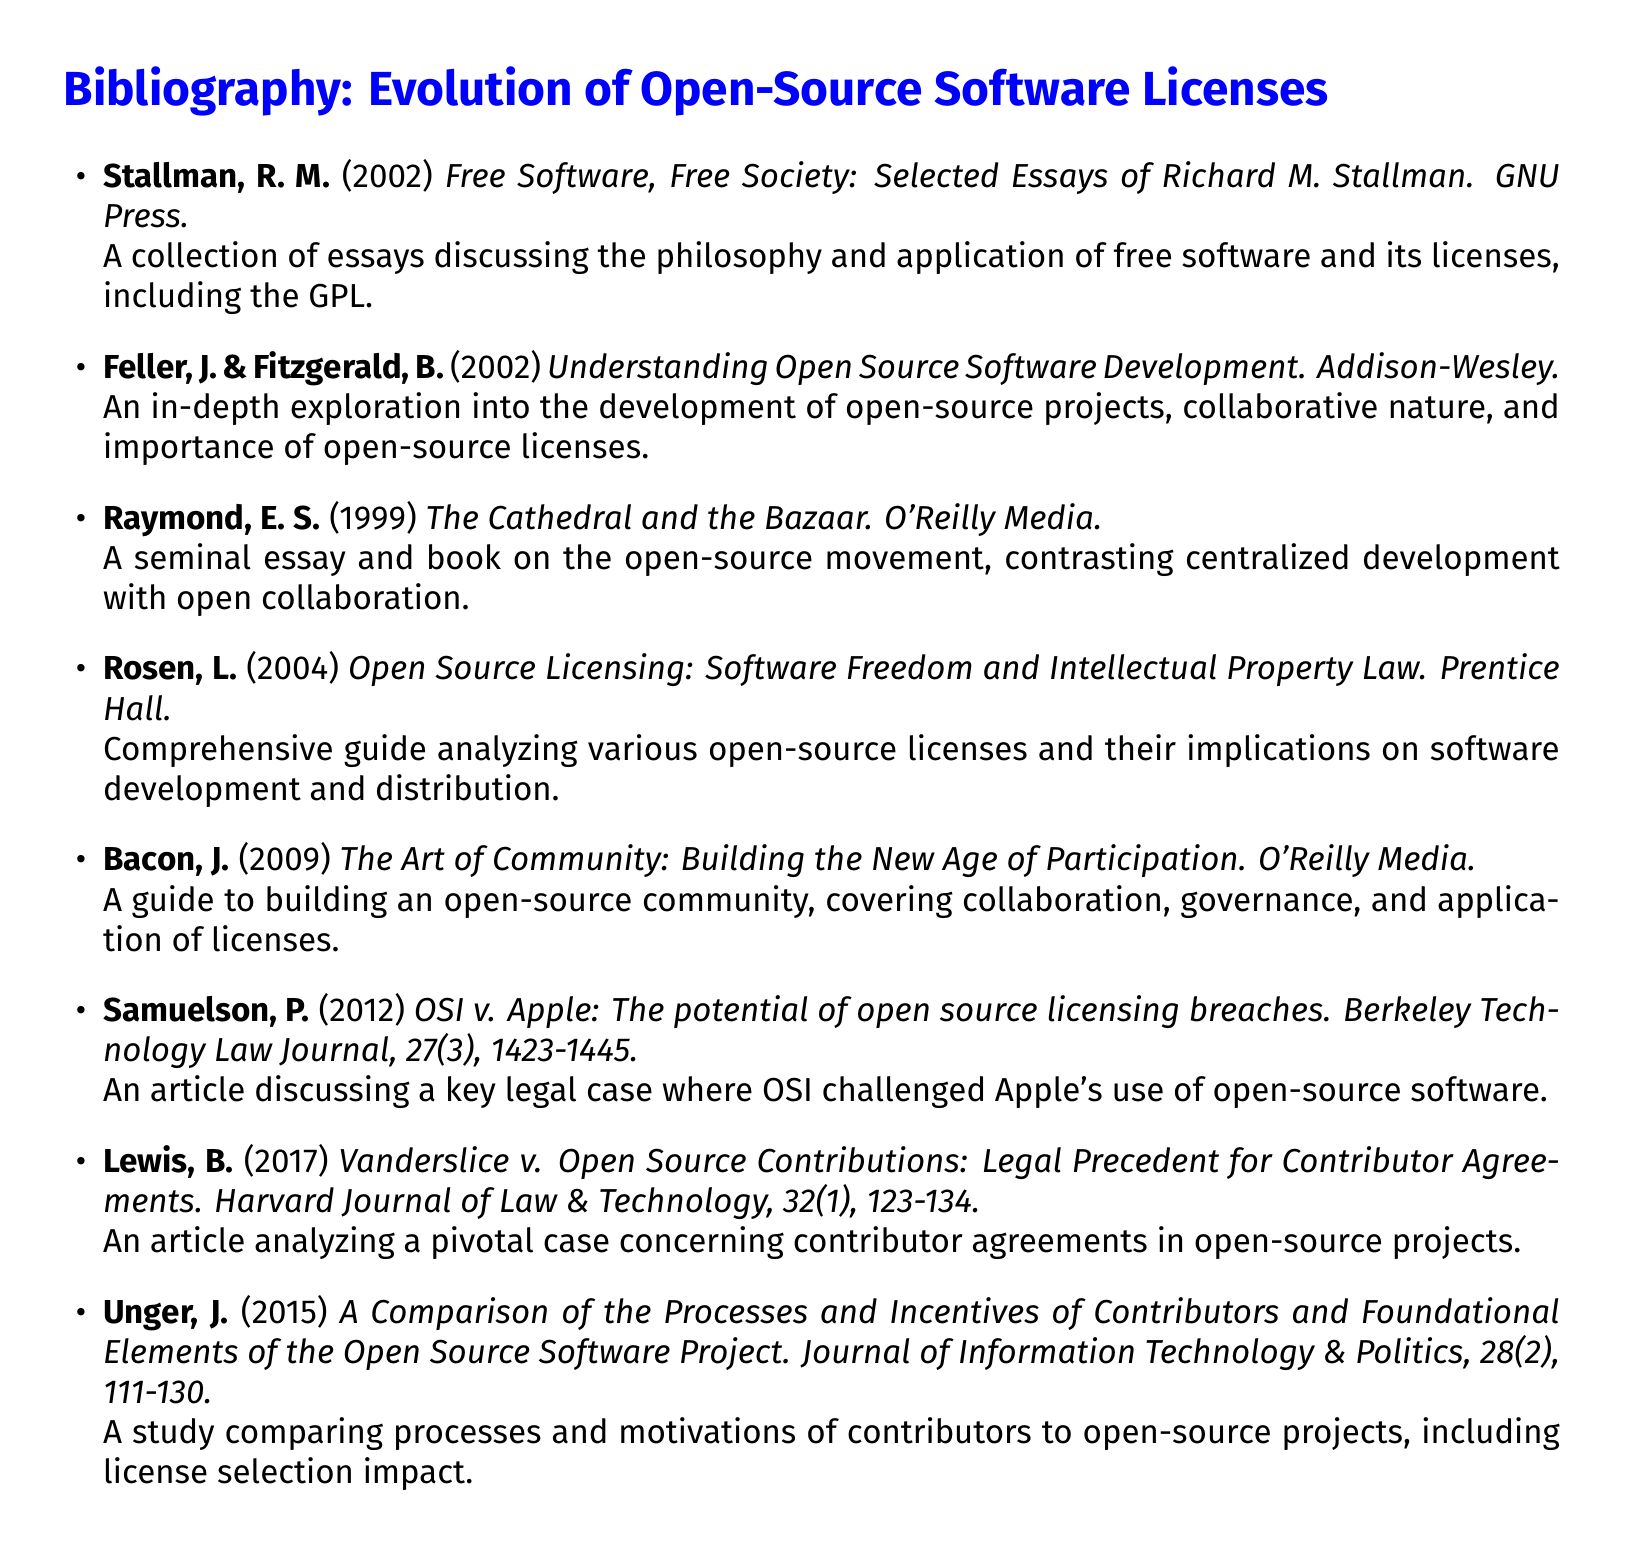What is the publication year of "Free Software, Free Society"? The publication year is listed next to the title in the document for each entry, which for "Free Software, Free Society" is 2002.
Answer: 2002 Who are the authors of "Understanding Open Source Software Development"? The authors' names are provided at the beginning of the entry, which are Feller and Fitzgerald.
Answer: Feller, J. & Fitzgerald, B What is the title of the work by Rosen? The title is included in the entry and is "Open Source Licensing: Software Freedom and Intellectual Property Law."
Answer: Open Source Licensing: Software Freedom and Intellectual Property Law Which journal published the article regarding OSI v. Apple? The journal name is noted within the entry for that article, which is the Berkeley Technology Law Journal.
Answer: Berkeley Technology Law Journal What is the main topic of the article by Lewis? The main topic is described in the description part of the entry, relating it to contributor agreements in open-source projects.
Answer: Contributor agreements Which author discusses the open-source movement in a seminal essay? The author is noted at the beginning of the entry where the work is mentioned, which is Eric S. Raymond.
Answer: Eric S. Raymond How many entries are focused on legal cases? The count of entries that address legal cases can be gathered by looking at the relevant descriptions, which are two in total: by Samuelson and Lewis.
Answer: 2 What is the publisher of "The Art of Community"? The publisher's name is provided at the end of the entry for that work, which is O'Reilly Media.
Answer: O'Reilly Media What is the page number range of Samuelson's article? The page number range is included in the citation of the article in the document, which is 1423-1445.
Answer: 1423-1445 